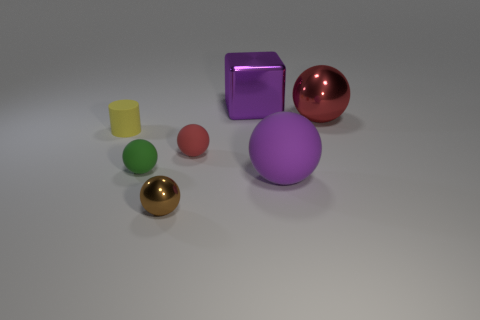Subtract all yellow cylinders. How many red balls are left? 2 Subtract all small brown metal balls. How many balls are left? 4 Subtract 2 spheres. How many spheres are left? 3 Add 1 tiny red matte objects. How many objects exist? 8 Subtract all purple spheres. How many spheres are left? 4 Subtract 1 yellow cylinders. How many objects are left? 6 Subtract all balls. How many objects are left? 2 Subtract all cyan balls. Subtract all cyan cylinders. How many balls are left? 5 Subtract all tiny cylinders. Subtract all big purple metal objects. How many objects are left? 5 Add 5 small yellow cylinders. How many small yellow cylinders are left? 6 